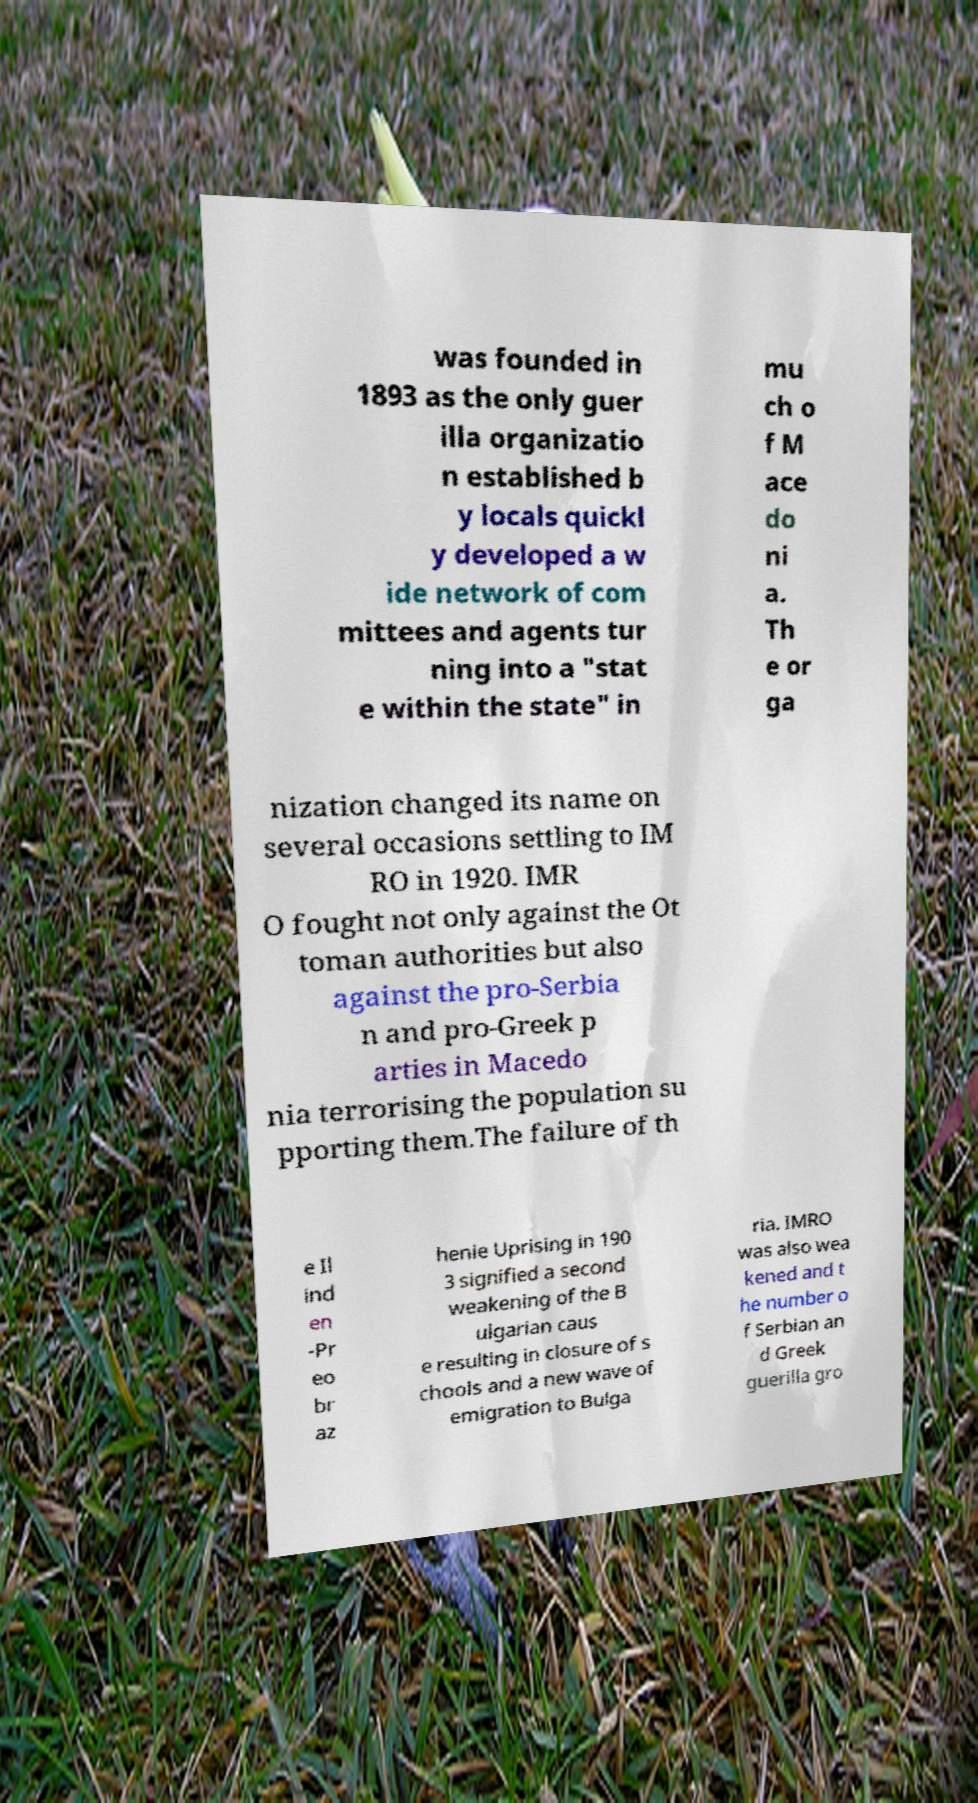Could you extract and type out the text from this image? was founded in 1893 as the only guer illa organizatio n established b y locals quickl y developed a w ide network of com mittees and agents tur ning into a "stat e within the state" in mu ch o f M ace do ni a. Th e or ga nization changed its name on several occasions settling to IM RO in 1920. IMR O fought not only against the Ot toman authorities but also against the pro-Serbia n and pro-Greek p arties in Macedo nia terrorising the population su pporting them.The failure of th e Il ind en -Pr eo br az henie Uprising in 190 3 signified a second weakening of the B ulgarian caus e resulting in closure of s chools and a new wave of emigration to Bulga ria. IMRO was also wea kened and t he number o f Serbian an d Greek guerilla gro 